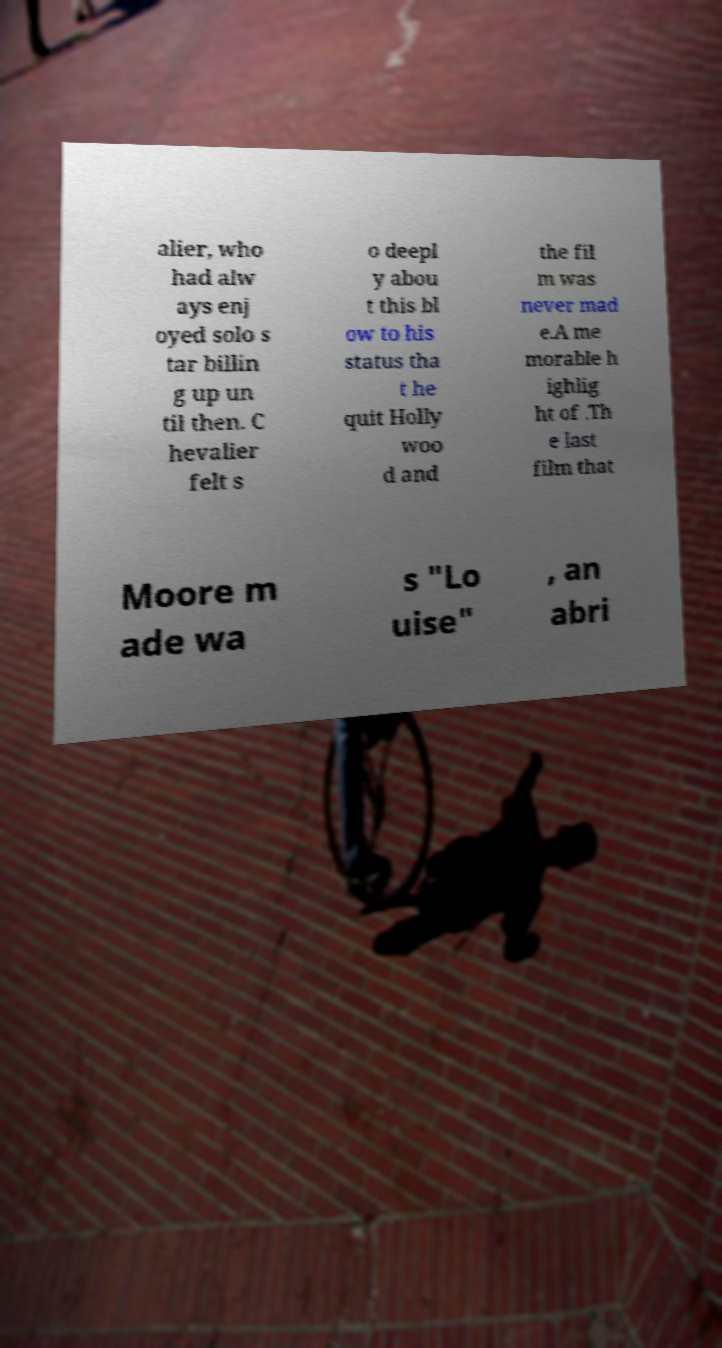There's text embedded in this image that I need extracted. Can you transcribe it verbatim? alier, who had alw ays enj oyed solo s tar billin g up un til then. C hevalier felt s o deepl y abou t this bl ow to his status tha t he quit Holly woo d and the fil m was never mad e.A me morable h ighlig ht of .Th e last film that Moore m ade wa s "Lo uise" , an abri 